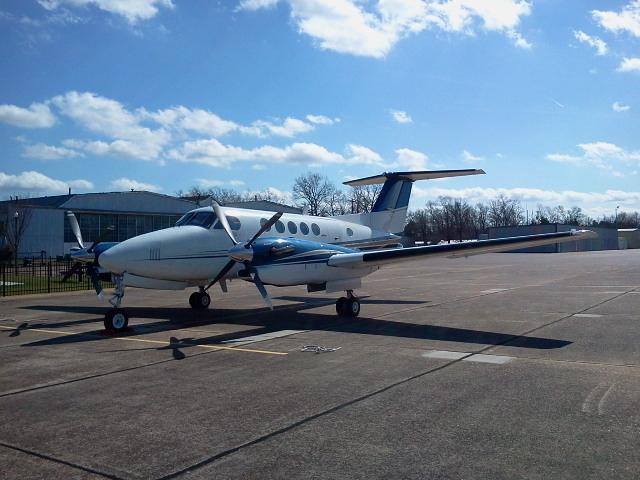Are there clouds?
Quick response, please. Yes. Is this a large airport?
Answer briefly. No. How many propeller blades are there all together?
Concise answer only. 8. 